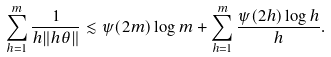Convert formula to latex. <formula><loc_0><loc_0><loc_500><loc_500>\sum _ { h = 1 } ^ { m } \frac { 1 } { h \| h \theta \| } \lesssim \psi ( 2 m ) \log m + \sum _ { h = 1 } ^ { m } \frac { \psi ( 2 h ) \log h } { h } .</formula> 